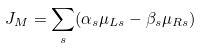<formula> <loc_0><loc_0><loc_500><loc_500>J _ { M } = \sum _ { s } ( \alpha _ { s } \mu _ { L s } - \beta _ { s } \mu _ { R s } )</formula> 